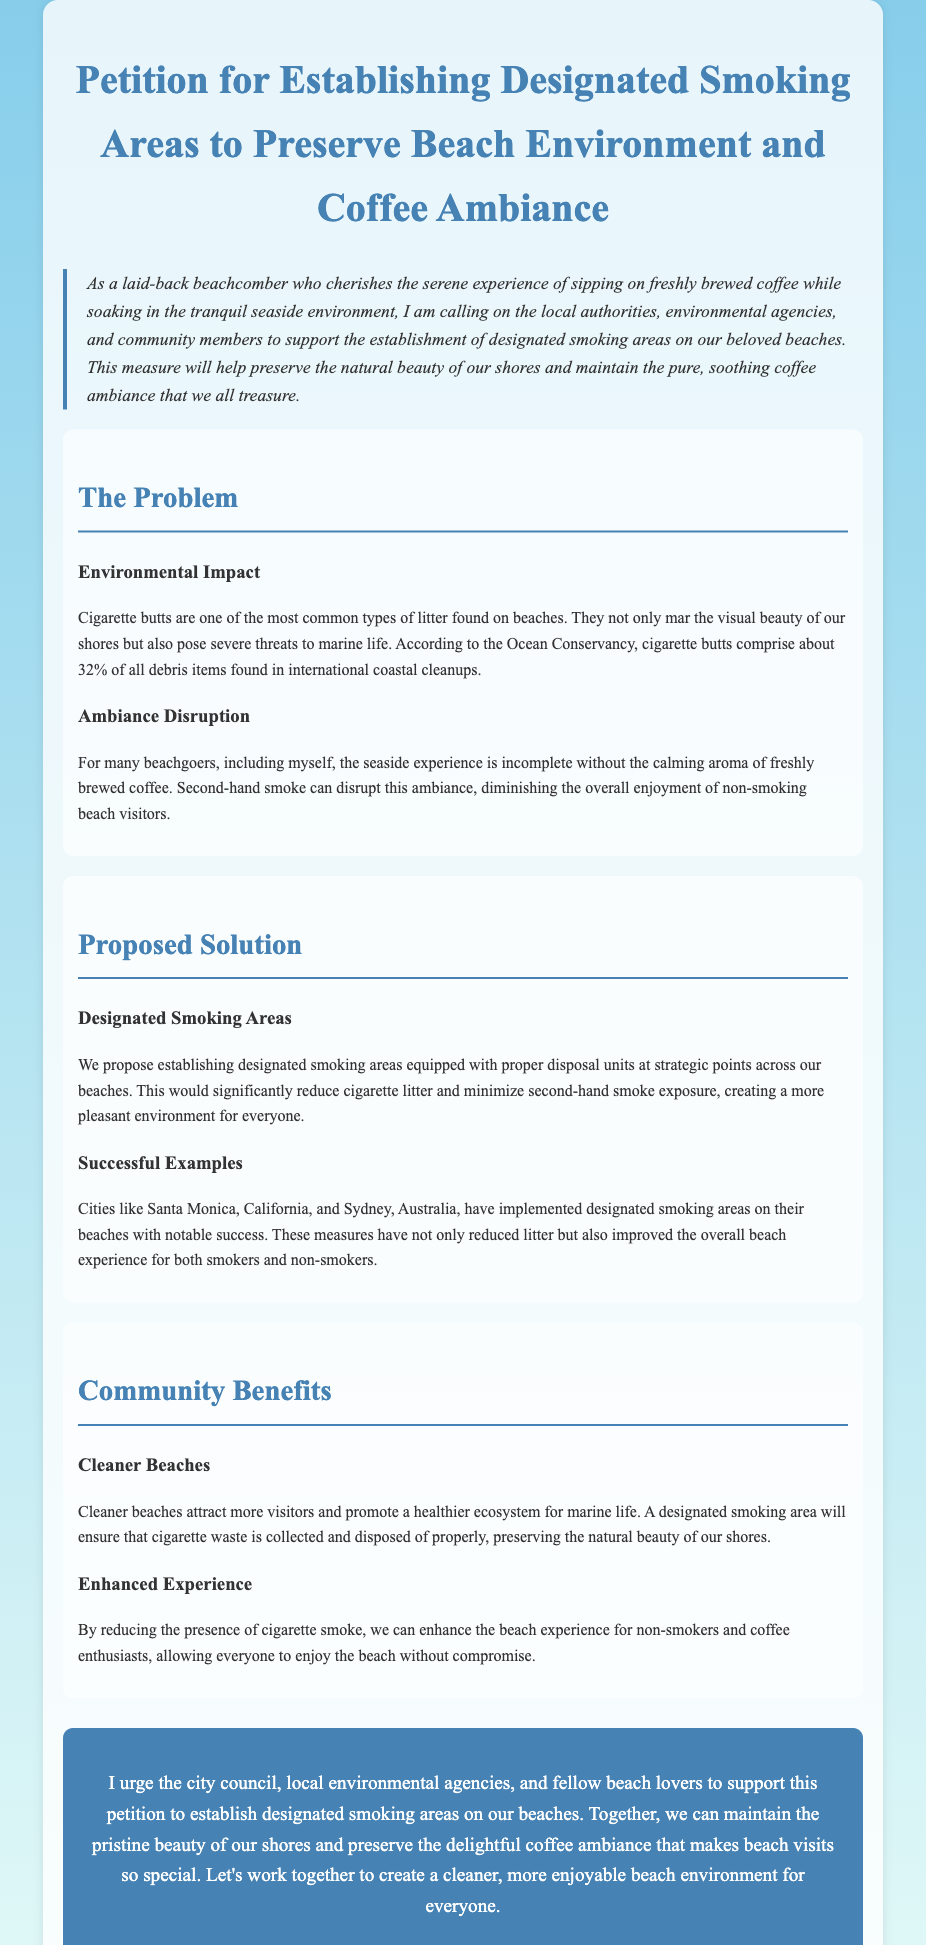What is the main purpose of the petition? The main purpose of the petition is to call for the establishment of designated smoking areas to preserve the beach environment and coffee ambiance.
Answer: To establish designated smoking areas What percentage of debris items found in coastal cleanups are cigarette butts? The document states that cigarette butts comprise about 32% of all debris items found in international coastal cleanups.
Answer: 32% What is one successful example city mentioned for implementing designated smoking areas? The document cites Santa Monica, California, as a successful example of implementing designated smoking areas.
Answer: Santa Monica How do designated smoking areas benefit non-smokers? Establishing designated smoking areas is proposed to reduce the presence of cigarette smoke, enhancing the beach experience for non-smokers and coffee enthusiasts.
Answer: By reducing cigarette smoke What should be located at the designated smoking areas? The petition suggests that designated smoking areas should be equipped with proper disposal units.
Answer: Proper disposal units What is one key community benefit of cleaner beaches mentioned? Cleaner beaches are said to attract more visitors and promote a healthier ecosystem for marine life.
Answer: Attract more visitors What specific aroma is mentioned as enhancing the beach experience? The calming aroma of freshly brewed coffee is mentioned as enhancing the beach experience.
Answer: Freshly brewed coffee What is the style of this document? The document is styled as a petition advocating for environmental preservation and community well-being.
Answer: Petition 